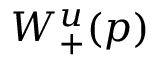Convert formula to latex. <formula><loc_0><loc_0><loc_500><loc_500>W _ { + } ^ { u } ( p )</formula> 